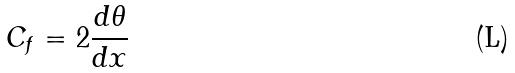<formula> <loc_0><loc_0><loc_500><loc_500>C _ { f } = 2 \frac { d \theta } { d x }</formula> 